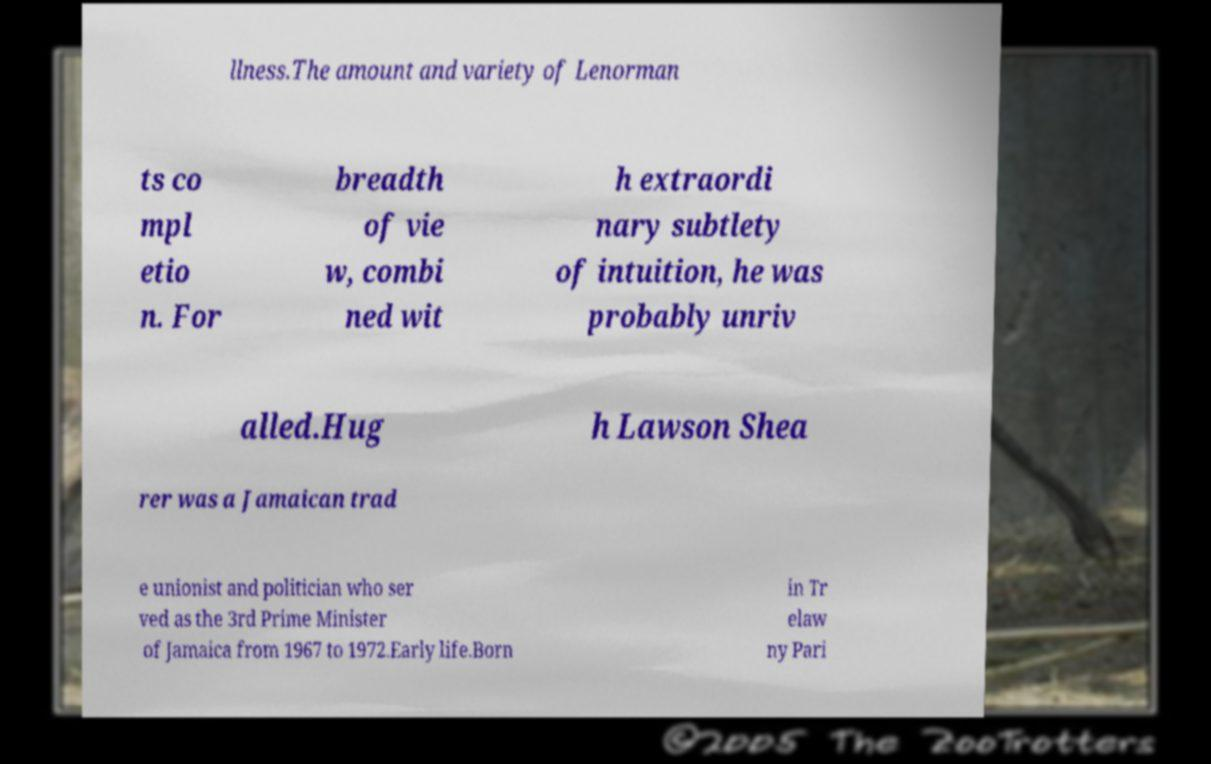For documentation purposes, I need the text within this image transcribed. Could you provide that? llness.The amount and variety of Lenorman ts co mpl etio n. For breadth of vie w, combi ned wit h extraordi nary subtlety of intuition, he was probably unriv alled.Hug h Lawson Shea rer was a Jamaican trad e unionist and politician who ser ved as the 3rd Prime Minister of Jamaica from 1967 to 1972.Early life.Born in Tr elaw ny Pari 